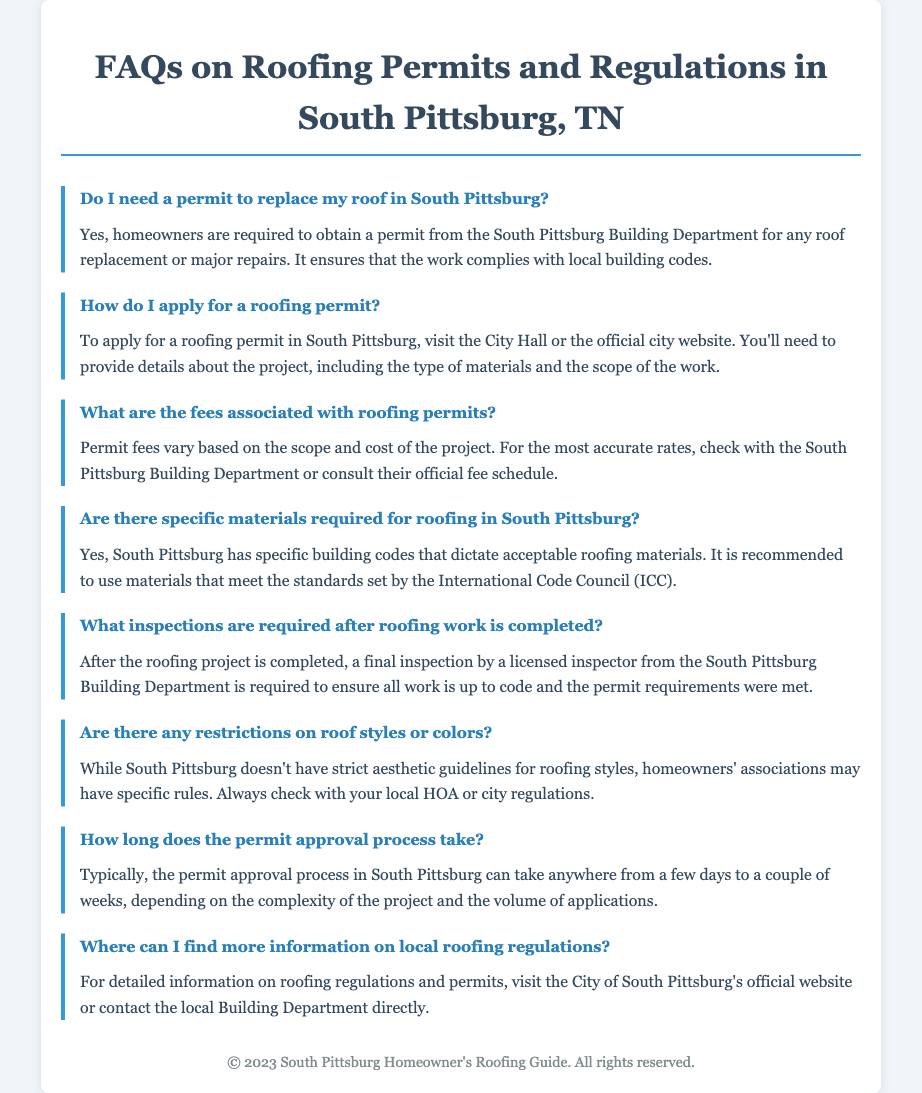Do I need a permit to replace my roof? The document states that homeowners are required to obtain a permit from the South Pittsburg Building Department for roof replacement or major repairs.
Answer: Yes How do I apply for a roofing permit? The document indicates that homeowners can apply for a roofing permit by visiting City Hall or the official city website.
Answer: Visit City Hall or the official city website What are the fees for roofing permits? The document mentions that permit fees vary based on the scope and cost of the project and suggests checking with the South Pittsburg Building Department.
Answer: Vary based on the project What inspections are required after roofing work? According to the document, a final inspection by a licensed inspector from the South Pittsburg Building Department is required after completion.
Answer: Final inspection How long does the permit approval process take? The document states that the permit approval process typically takes anywhere from a few days to a couple of weeks.
Answer: Few days to a couple of weeks Where can I find more information on roofing regulations? The document advises visiting the City of South Pittsburg's official website or contacting the local Building Department for detailed information.
Answer: Official website or local Building Department 